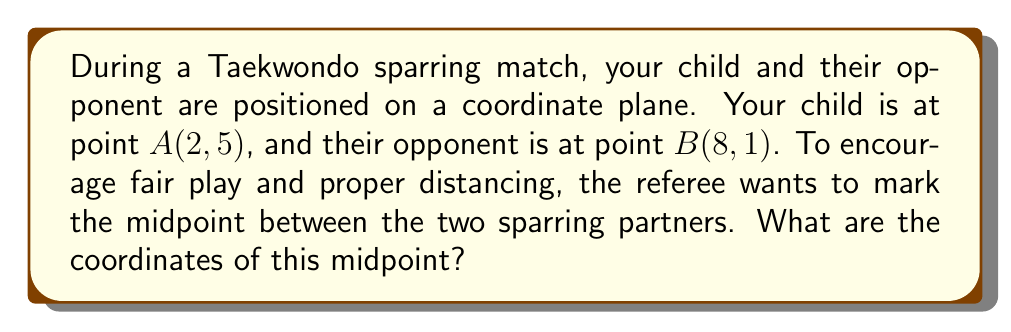Solve this math problem. Let's approach this step-by-step:

1) The midpoint formula is used to find the point exactly halfway between two given points. For two points $(x_1, y_1)$ and $(x_2, y_2)$, the midpoint is calculated as:

   $$ \left(\frac{x_1 + x_2}{2}, \frac{y_1 + y_2}{2}\right) $$

2) In this case, we have:
   Point A: $(x_1, y_1) = (2, 5)$
   Point B: $(x_2, y_2) = (8, 1)$

3) Let's substitute these values into the midpoint formula:

   $$ \left(\frac{2 + 8}{2}, \frac{5 + 1}{2}\right) $$

4) Now, let's solve each part separately:

   For the x-coordinate: $\frac{2 + 8}{2} = \frac{10}{2} = 5$

   For the y-coordinate: $\frac{5 + 1}{2} = \frac{6}{2} = 3$

5) Therefore, the midpoint is (5, 3).

This point represents where the referee should stand to maintain equal distance from both sparring partners, ensuring fair play and proper distancing during the match.

[asy]
unitsize(1cm);
draw((-1,-1)--(10,7),gray);
draw((-1,0)--(10,0),gray);
draw((0,-1)--(0,7),gray);
for(int i=-1; i<=10; ++i) {
  draw((i,-0.1)--(i,0.1),gray);
  label(string(i),(i,-0.5),fontsize(8));
}
for(int i=-1; i<=7; ++i) {
  draw((-0.1,i)--(0.1,i),gray);
  label(string(i),(-0.5,i),fontsize(8));
}
dot((2,5),red);
dot((8,1),blue);
dot((5,3),green);
label("A(2,5)",(2,5),NE,red);
label("B(8,1)",(8,1),SE,blue);
label("Midpoint(5,3)",(5,3),N,green);
[/asy]
Answer: The coordinates of the midpoint are (5, 3). 